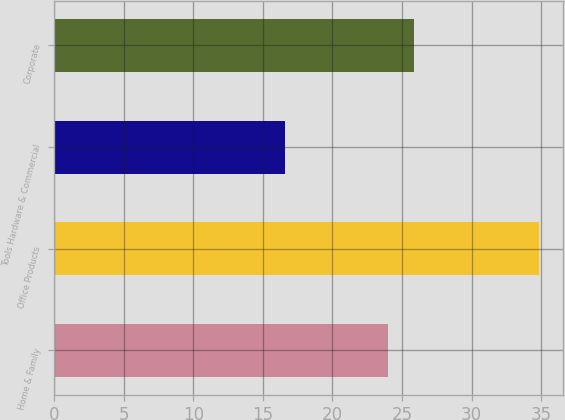Convert chart to OTSL. <chart><loc_0><loc_0><loc_500><loc_500><bar_chart><fcel>Home & Family<fcel>Office Products<fcel>Tools Hardware & Commercial<fcel>Corporate<nl><fcel>24<fcel>34.8<fcel>16.6<fcel>25.82<nl></chart> 